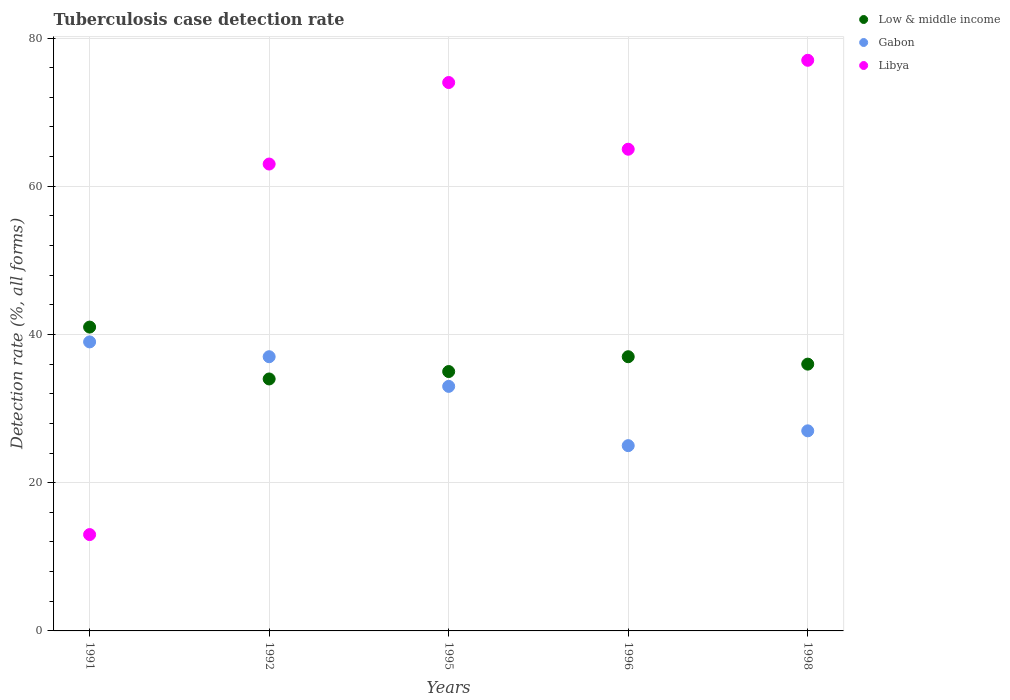Is the number of dotlines equal to the number of legend labels?
Your answer should be compact. Yes. Across all years, what is the maximum tuberculosis case detection rate in in Low & middle income?
Make the answer very short. 41. Across all years, what is the minimum tuberculosis case detection rate in in Gabon?
Keep it short and to the point. 25. In which year was the tuberculosis case detection rate in in Libya maximum?
Offer a very short reply. 1998. In which year was the tuberculosis case detection rate in in Libya minimum?
Your answer should be very brief. 1991. What is the total tuberculosis case detection rate in in Low & middle income in the graph?
Make the answer very short. 183. What is the average tuberculosis case detection rate in in Libya per year?
Provide a succinct answer. 58.4. In the year 1995, what is the difference between the tuberculosis case detection rate in in Gabon and tuberculosis case detection rate in in Libya?
Make the answer very short. -41. What is the ratio of the tuberculosis case detection rate in in Libya in 1996 to that in 1998?
Your response must be concise. 0.84. What is the difference between the highest and the lowest tuberculosis case detection rate in in Low & middle income?
Give a very brief answer. 7. In how many years, is the tuberculosis case detection rate in in Libya greater than the average tuberculosis case detection rate in in Libya taken over all years?
Provide a short and direct response. 4. Is the tuberculosis case detection rate in in Libya strictly less than the tuberculosis case detection rate in in Gabon over the years?
Offer a terse response. No. Are the values on the major ticks of Y-axis written in scientific E-notation?
Provide a short and direct response. No. What is the title of the graph?
Make the answer very short. Tuberculosis case detection rate. What is the label or title of the Y-axis?
Provide a short and direct response. Detection rate (%, all forms). What is the Detection rate (%, all forms) of Low & middle income in 1991?
Provide a short and direct response. 41. What is the Detection rate (%, all forms) of Gabon in 1992?
Your answer should be compact. 37. What is the Detection rate (%, all forms) in Low & middle income in 1995?
Provide a succinct answer. 35. What is the Detection rate (%, all forms) in Libya in 1995?
Keep it short and to the point. 74. What is the Detection rate (%, all forms) in Low & middle income in 1996?
Provide a succinct answer. 37. What is the Detection rate (%, all forms) of Libya in 1996?
Your answer should be compact. 65. Across all years, what is the maximum Detection rate (%, all forms) in Libya?
Give a very brief answer. 77. Across all years, what is the minimum Detection rate (%, all forms) of Gabon?
Your response must be concise. 25. What is the total Detection rate (%, all forms) of Low & middle income in the graph?
Your response must be concise. 183. What is the total Detection rate (%, all forms) of Gabon in the graph?
Ensure brevity in your answer.  161. What is the total Detection rate (%, all forms) in Libya in the graph?
Provide a succinct answer. 292. What is the difference between the Detection rate (%, all forms) of Low & middle income in 1991 and that in 1992?
Your answer should be very brief. 7. What is the difference between the Detection rate (%, all forms) of Low & middle income in 1991 and that in 1995?
Your answer should be very brief. 6. What is the difference between the Detection rate (%, all forms) in Libya in 1991 and that in 1995?
Your response must be concise. -61. What is the difference between the Detection rate (%, all forms) of Libya in 1991 and that in 1996?
Make the answer very short. -52. What is the difference between the Detection rate (%, all forms) in Libya in 1991 and that in 1998?
Offer a very short reply. -64. What is the difference between the Detection rate (%, all forms) of Gabon in 1992 and that in 1995?
Give a very brief answer. 4. What is the difference between the Detection rate (%, all forms) of Libya in 1992 and that in 1995?
Provide a succinct answer. -11. What is the difference between the Detection rate (%, all forms) in Low & middle income in 1992 and that in 1996?
Provide a short and direct response. -3. What is the difference between the Detection rate (%, all forms) of Libya in 1992 and that in 1996?
Provide a short and direct response. -2. What is the difference between the Detection rate (%, all forms) in Low & middle income in 1992 and that in 1998?
Make the answer very short. -2. What is the difference between the Detection rate (%, all forms) in Low & middle income in 1995 and that in 1996?
Your answer should be compact. -2. What is the difference between the Detection rate (%, all forms) of Gabon in 1995 and that in 1998?
Your answer should be very brief. 6. What is the difference between the Detection rate (%, all forms) in Low & middle income in 1991 and the Detection rate (%, all forms) in Gabon in 1992?
Offer a terse response. 4. What is the difference between the Detection rate (%, all forms) in Low & middle income in 1991 and the Detection rate (%, all forms) in Gabon in 1995?
Ensure brevity in your answer.  8. What is the difference between the Detection rate (%, all forms) of Low & middle income in 1991 and the Detection rate (%, all forms) of Libya in 1995?
Your answer should be compact. -33. What is the difference between the Detection rate (%, all forms) of Gabon in 1991 and the Detection rate (%, all forms) of Libya in 1995?
Your answer should be compact. -35. What is the difference between the Detection rate (%, all forms) in Low & middle income in 1991 and the Detection rate (%, all forms) in Libya in 1996?
Your answer should be very brief. -24. What is the difference between the Detection rate (%, all forms) in Low & middle income in 1991 and the Detection rate (%, all forms) in Gabon in 1998?
Provide a short and direct response. 14. What is the difference between the Detection rate (%, all forms) in Low & middle income in 1991 and the Detection rate (%, all forms) in Libya in 1998?
Offer a terse response. -36. What is the difference between the Detection rate (%, all forms) in Gabon in 1991 and the Detection rate (%, all forms) in Libya in 1998?
Ensure brevity in your answer.  -38. What is the difference between the Detection rate (%, all forms) of Gabon in 1992 and the Detection rate (%, all forms) of Libya in 1995?
Give a very brief answer. -37. What is the difference between the Detection rate (%, all forms) of Low & middle income in 1992 and the Detection rate (%, all forms) of Libya in 1996?
Keep it short and to the point. -31. What is the difference between the Detection rate (%, all forms) of Low & middle income in 1992 and the Detection rate (%, all forms) of Gabon in 1998?
Ensure brevity in your answer.  7. What is the difference between the Detection rate (%, all forms) of Low & middle income in 1992 and the Detection rate (%, all forms) of Libya in 1998?
Offer a very short reply. -43. What is the difference between the Detection rate (%, all forms) of Gabon in 1995 and the Detection rate (%, all forms) of Libya in 1996?
Your answer should be compact. -32. What is the difference between the Detection rate (%, all forms) in Low & middle income in 1995 and the Detection rate (%, all forms) in Gabon in 1998?
Provide a succinct answer. 8. What is the difference between the Detection rate (%, all forms) in Low & middle income in 1995 and the Detection rate (%, all forms) in Libya in 1998?
Provide a short and direct response. -42. What is the difference between the Detection rate (%, all forms) of Gabon in 1995 and the Detection rate (%, all forms) of Libya in 1998?
Give a very brief answer. -44. What is the difference between the Detection rate (%, all forms) in Low & middle income in 1996 and the Detection rate (%, all forms) in Gabon in 1998?
Offer a very short reply. 10. What is the difference between the Detection rate (%, all forms) of Gabon in 1996 and the Detection rate (%, all forms) of Libya in 1998?
Your answer should be compact. -52. What is the average Detection rate (%, all forms) in Low & middle income per year?
Keep it short and to the point. 36.6. What is the average Detection rate (%, all forms) of Gabon per year?
Offer a terse response. 32.2. What is the average Detection rate (%, all forms) of Libya per year?
Offer a terse response. 58.4. In the year 1991, what is the difference between the Detection rate (%, all forms) in Gabon and Detection rate (%, all forms) in Libya?
Your response must be concise. 26. In the year 1992, what is the difference between the Detection rate (%, all forms) in Low & middle income and Detection rate (%, all forms) in Gabon?
Give a very brief answer. -3. In the year 1992, what is the difference between the Detection rate (%, all forms) in Low & middle income and Detection rate (%, all forms) in Libya?
Give a very brief answer. -29. In the year 1995, what is the difference between the Detection rate (%, all forms) in Low & middle income and Detection rate (%, all forms) in Gabon?
Make the answer very short. 2. In the year 1995, what is the difference between the Detection rate (%, all forms) in Low & middle income and Detection rate (%, all forms) in Libya?
Provide a succinct answer. -39. In the year 1995, what is the difference between the Detection rate (%, all forms) in Gabon and Detection rate (%, all forms) in Libya?
Your answer should be very brief. -41. In the year 1996, what is the difference between the Detection rate (%, all forms) in Low & middle income and Detection rate (%, all forms) in Gabon?
Your response must be concise. 12. In the year 1996, what is the difference between the Detection rate (%, all forms) of Gabon and Detection rate (%, all forms) of Libya?
Give a very brief answer. -40. In the year 1998, what is the difference between the Detection rate (%, all forms) in Low & middle income and Detection rate (%, all forms) in Libya?
Your response must be concise. -41. What is the ratio of the Detection rate (%, all forms) in Low & middle income in 1991 to that in 1992?
Offer a terse response. 1.21. What is the ratio of the Detection rate (%, all forms) in Gabon in 1991 to that in 1992?
Your response must be concise. 1.05. What is the ratio of the Detection rate (%, all forms) in Libya in 1991 to that in 1992?
Offer a terse response. 0.21. What is the ratio of the Detection rate (%, all forms) in Low & middle income in 1991 to that in 1995?
Your response must be concise. 1.17. What is the ratio of the Detection rate (%, all forms) of Gabon in 1991 to that in 1995?
Your response must be concise. 1.18. What is the ratio of the Detection rate (%, all forms) of Libya in 1991 to that in 1995?
Ensure brevity in your answer.  0.18. What is the ratio of the Detection rate (%, all forms) of Low & middle income in 1991 to that in 1996?
Offer a terse response. 1.11. What is the ratio of the Detection rate (%, all forms) in Gabon in 1991 to that in 1996?
Make the answer very short. 1.56. What is the ratio of the Detection rate (%, all forms) in Low & middle income in 1991 to that in 1998?
Ensure brevity in your answer.  1.14. What is the ratio of the Detection rate (%, all forms) in Gabon in 1991 to that in 1998?
Make the answer very short. 1.44. What is the ratio of the Detection rate (%, all forms) in Libya in 1991 to that in 1998?
Your answer should be very brief. 0.17. What is the ratio of the Detection rate (%, all forms) in Low & middle income in 1992 to that in 1995?
Provide a succinct answer. 0.97. What is the ratio of the Detection rate (%, all forms) of Gabon in 1992 to that in 1995?
Your answer should be very brief. 1.12. What is the ratio of the Detection rate (%, all forms) of Libya in 1992 to that in 1995?
Offer a very short reply. 0.85. What is the ratio of the Detection rate (%, all forms) in Low & middle income in 1992 to that in 1996?
Your answer should be compact. 0.92. What is the ratio of the Detection rate (%, all forms) in Gabon in 1992 to that in 1996?
Keep it short and to the point. 1.48. What is the ratio of the Detection rate (%, all forms) of Libya in 1992 to that in 1996?
Provide a short and direct response. 0.97. What is the ratio of the Detection rate (%, all forms) in Low & middle income in 1992 to that in 1998?
Offer a very short reply. 0.94. What is the ratio of the Detection rate (%, all forms) in Gabon in 1992 to that in 1998?
Your response must be concise. 1.37. What is the ratio of the Detection rate (%, all forms) in Libya in 1992 to that in 1998?
Ensure brevity in your answer.  0.82. What is the ratio of the Detection rate (%, all forms) in Low & middle income in 1995 to that in 1996?
Your answer should be very brief. 0.95. What is the ratio of the Detection rate (%, all forms) of Gabon in 1995 to that in 1996?
Give a very brief answer. 1.32. What is the ratio of the Detection rate (%, all forms) of Libya in 1995 to that in 1996?
Keep it short and to the point. 1.14. What is the ratio of the Detection rate (%, all forms) of Low & middle income in 1995 to that in 1998?
Your answer should be compact. 0.97. What is the ratio of the Detection rate (%, all forms) of Gabon in 1995 to that in 1998?
Your response must be concise. 1.22. What is the ratio of the Detection rate (%, all forms) in Libya in 1995 to that in 1998?
Your answer should be very brief. 0.96. What is the ratio of the Detection rate (%, all forms) in Low & middle income in 1996 to that in 1998?
Your answer should be very brief. 1.03. What is the ratio of the Detection rate (%, all forms) of Gabon in 1996 to that in 1998?
Your response must be concise. 0.93. What is the ratio of the Detection rate (%, all forms) in Libya in 1996 to that in 1998?
Offer a very short reply. 0.84. What is the difference between the highest and the second highest Detection rate (%, all forms) in Gabon?
Ensure brevity in your answer.  2. What is the difference between the highest and the second highest Detection rate (%, all forms) in Libya?
Make the answer very short. 3. What is the difference between the highest and the lowest Detection rate (%, all forms) of Low & middle income?
Offer a terse response. 7. 